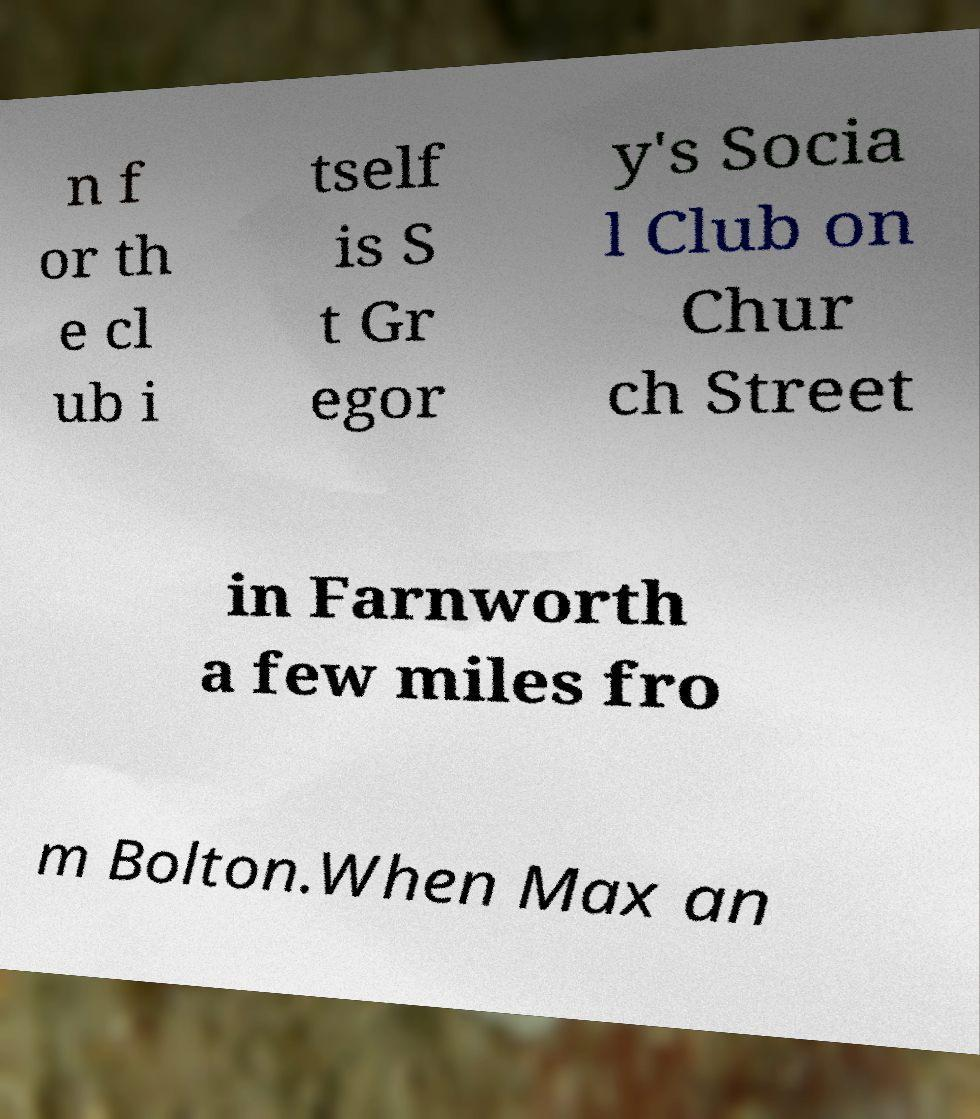I need the written content from this picture converted into text. Can you do that? n f or th e cl ub i tself is S t Gr egor y's Socia l Club on Chur ch Street in Farnworth a few miles fro m Bolton.When Max an 